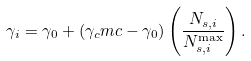Convert formula to latex. <formula><loc_0><loc_0><loc_500><loc_500>\gamma _ { i } = \gamma _ { 0 } + ( \gamma _ { c } m c - \gamma _ { 0 } ) \left ( \frac { N _ { s , i } } { N _ { s , i } ^ { \max } } \right ) .</formula> 